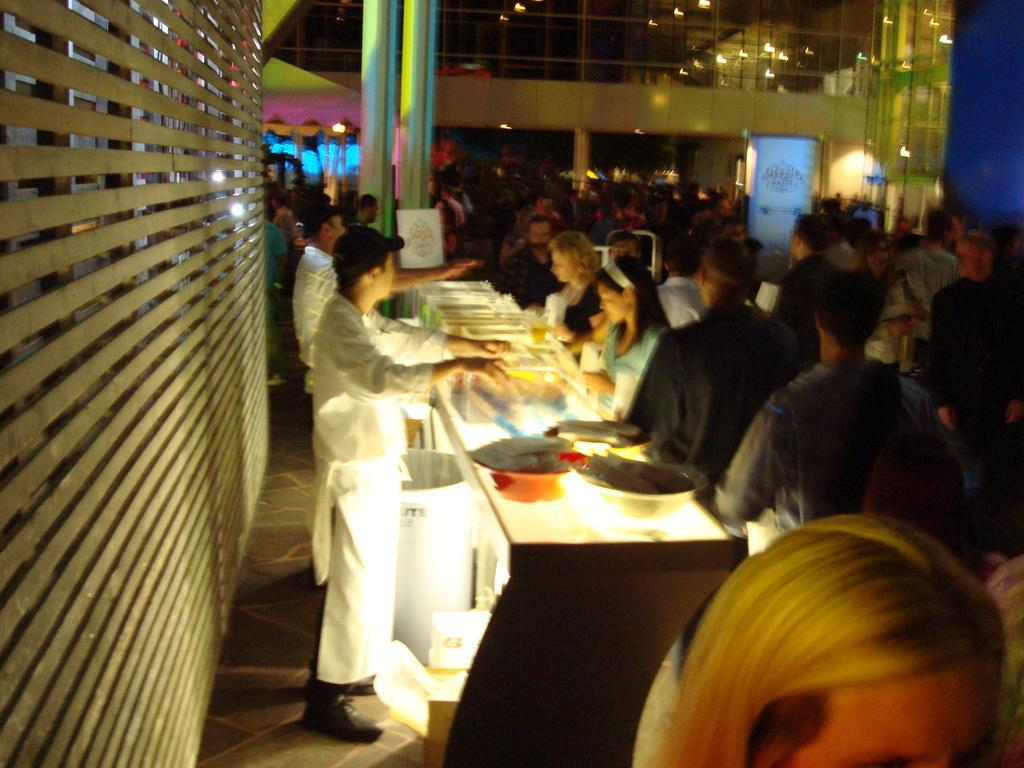How many people are present in the image? There are many people in the image. What can be seen on top in the image? There are lights on top in the image. What is located in the middle of the image? There is a pillar in the middle of the image. What is on the table in the image? There are bowls on the table. How are the people positioned in relation to the table? People are on both sides of the table. Can you tell me how many afterthoughts are visible in the image? There is no mention of "afterthoughts" in the image, so it is not possible to answer that question. Is there a bridge visible in the image? No, there is no bridge present in the image. 